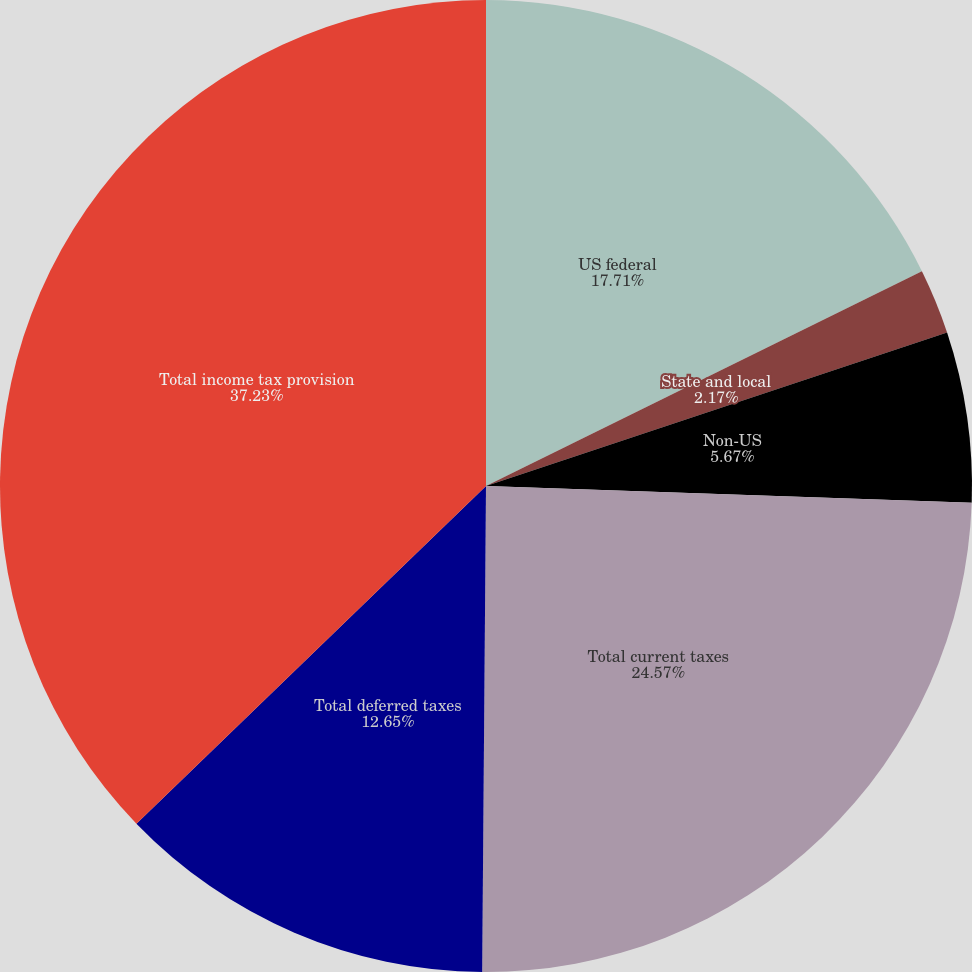Convert chart to OTSL. <chart><loc_0><loc_0><loc_500><loc_500><pie_chart><fcel>US federal<fcel>State and local<fcel>Non-US<fcel>Total current taxes<fcel>Total deferred taxes<fcel>Total income tax provision<nl><fcel>17.71%<fcel>2.17%<fcel>5.67%<fcel>24.57%<fcel>12.65%<fcel>37.22%<nl></chart> 